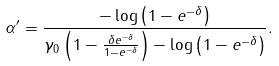Convert formula to latex. <formula><loc_0><loc_0><loc_500><loc_500>\alpha ^ { \prime } = \frac { - \log \left ( 1 - e ^ { - \delta } \right ) } { \gamma _ { 0 } \left ( 1 - \frac { \delta e ^ { - \delta } } { 1 - e ^ { - \delta } } \right ) - \log \left ( 1 - e ^ { - \delta } \right ) } .</formula> 